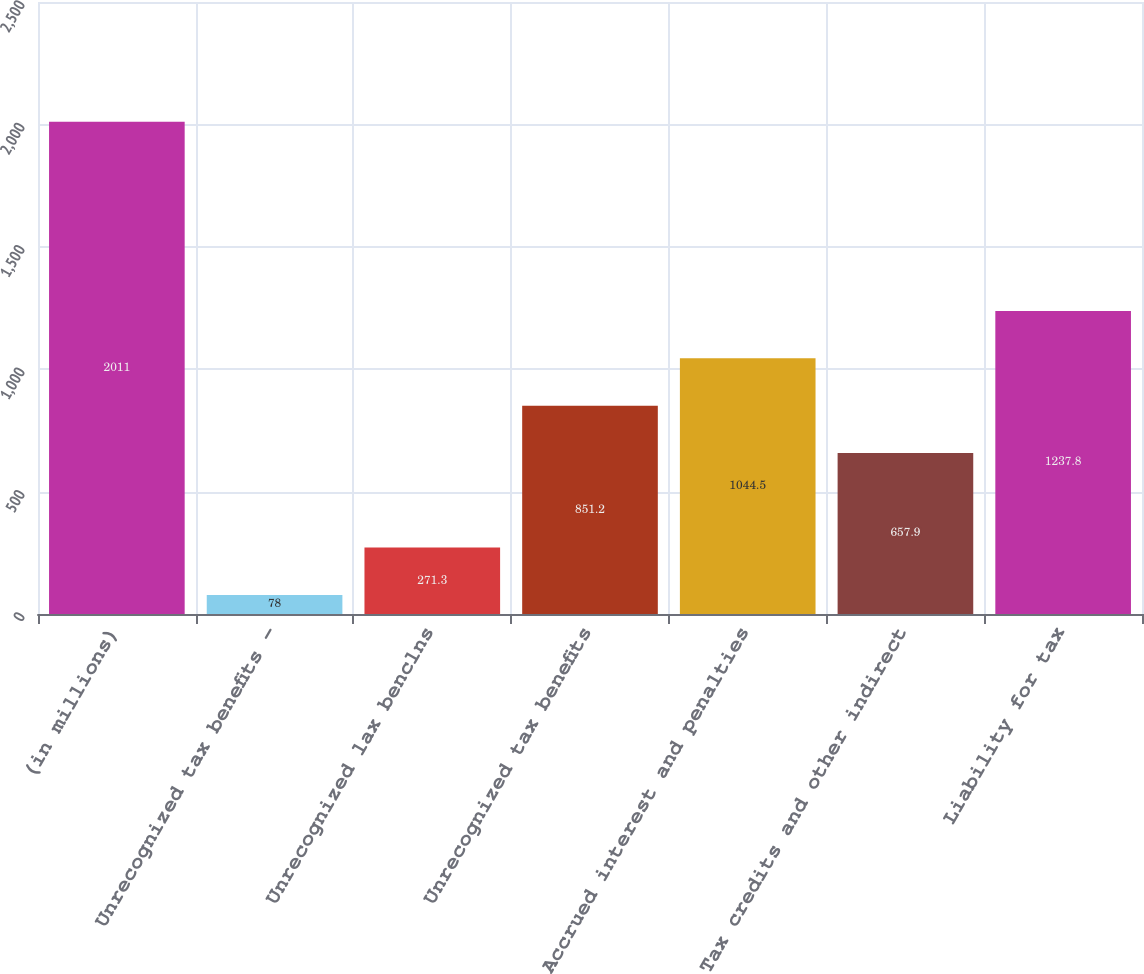Convert chart. <chart><loc_0><loc_0><loc_500><loc_500><bar_chart><fcel>(in millions)<fcel>Unrecognized tax benefits -<fcel>Unrecognized lax benclns<fcel>Unrecognized tax benefits<fcel>Accrued interest and penalties<fcel>Tax credits and other indirect<fcel>Liability for tax<nl><fcel>2011<fcel>78<fcel>271.3<fcel>851.2<fcel>1044.5<fcel>657.9<fcel>1237.8<nl></chart> 